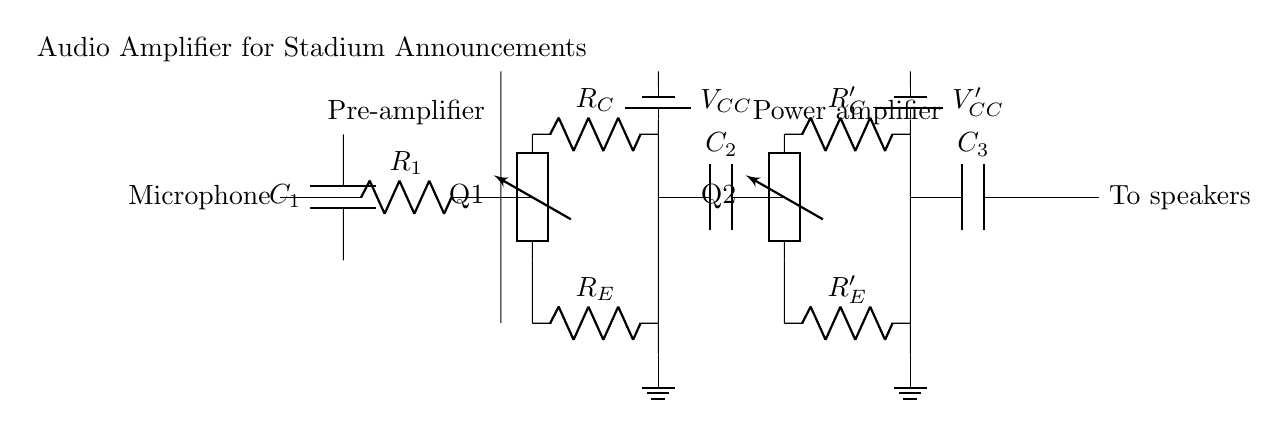What is the main component for sound input? The main component for sound input is the microphone, which is clearly labeled in the circuit diagram. It serves as the source of audio signals that are then amplified.
Answer: Microphone What component is used to couple the input signal? The component used to couple the input signal is the capacitor labeled C1. Capacitors are commonly used for this purpose to block DC voltages while allowing AC signals (like audio) to pass.
Answer: C1 How many transistors are present in the circuit? There are two transistors present in the circuit, identified as Q1 and Q2. Each transistor acts as an amplification device within its respective amplification stage.
Answer: 2 What is the role of R1 in the circuit? R1 functions as a load resistor in the pre-amplifier section, helping to set the operating point of the transistor Q1 and controlling the amount of gain in that stage of the circuit.
Answer: Load resistor What is the supply voltage for the power amplifier? The supply voltage for the power amplifier is indicated as VCC prime, which provides the necessary power for the functioning of the second transistor Q2 and the associated components.
Answer: VCC prime Which two components are responsible for output coupling? The output coupling is achieved through capacitors C2 and C3, which isolate the amplified audio signal from the DC supply voltage, allowing only the AC audio to be sent to the speakers.
Answer: C2 and C3 What is the purpose of the resistor R_E? The resistor R_E, labeled as Emitter Resistor in the first amplifier stage, serves to provide stability to the circuit by setting the biasing of the transistor Q1, thus affecting gain and linearity.
Answer: Stability 